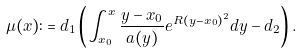Convert formula to latex. <formula><loc_0><loc_0><loc_500><loc_500>\mu ( x ) \colon = d _ { 1 } \left ( \int _ { x _ { 0 } } ^ { x } \frac { y - x _ { 0 } } { a ( y ) } e ^ { R ( y - x _ { 0 } ) ^ { 2 } } d y - d _ { 2 } \right ) .</formula> 